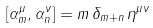<formula> <loc_0><loc_0><loc_500><loc_500>[ \alpha _ { m } ^ { \mu } , \alpha _ { n } ^ { \nu } ] = m \, \delta _ { m + n } \, \eta ^ { \mu \nu }</formula> 